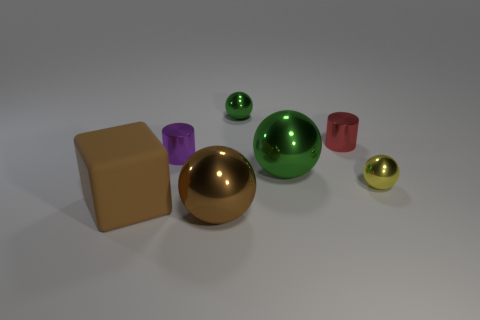Subtract all yellow spheres. How many spheres are left? 3 Subtract all brown blocks. How many green spheres are left? 2 Subtract all yellow spheres. How many spheres are left? 3 Add 1 tiny brown cylinders. How many objects exist? 8 Subtract all purple balls. Subtract all purple cylinders. How many balls are left? 4 Subtract all cylinders. How many objects are left? 5 Add 3 brown objects. How many brown objects exist? 5 Subtract 0 cyan cubes. How many objects are left? 7 Subtract all purple cylinders. Subtract all small green shiny balls. How many objects are left? 5 Add 4 brown spheres. How many brown spheres are left? 5 